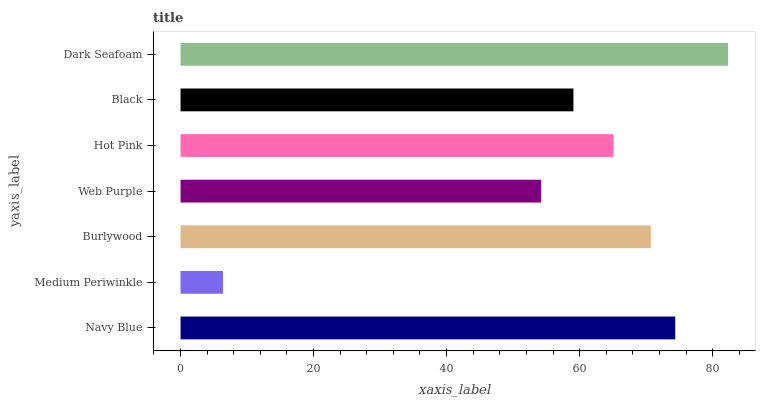Is Medium Periwinkle the minimum?
Answer yes or no. Yes. Is Dark Seafoam the maximum?
Answer yes or no. Yes. Is Burlywood the minimum?
Answer yes or no. No. Is Burlywood the maximum?
Answer yes or no. No. Is Burlywood greater than Medium Periwinkle?
Answer yes or no. Yes. Is Medium Periwinkle less than Burlywood?
Answer yes or no. Yes. Is Medium Periwinkle greater than Burlywood?
Answer yes or no. No. Is Burlywood less than Medium Periwinkle?
Answer yes or no. No. Is Hot Pink the high median?
Answer yes or no. Yes. Is Hot Pink the low median?
Answer yes or no. Yes. Is Dark Seafoam the high median?
Answer yes or no. No. Is Web Purple the low median?
Answer yes or no. No. 